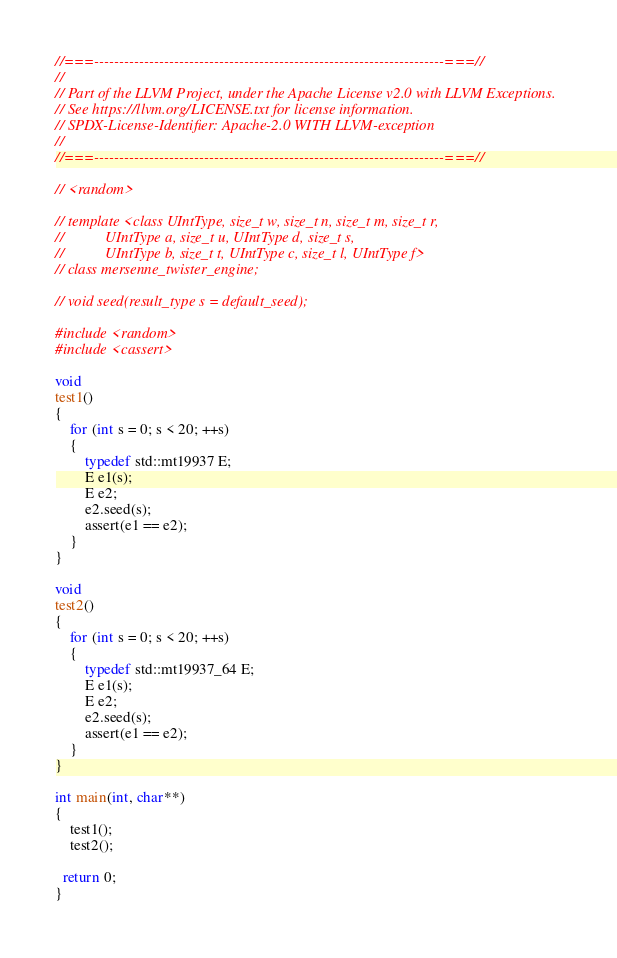Convert code to text. <code><loc_0><loc_0><loc_500><loc_500><_C++_>//===----------------------------------------------------------------------===//
//
// Part of the LLVM Project, under the Apache License v2.0 with LLVM Exceptions.
// See https://llvm.org/LICENSE.txt for license information.
// SPDX-License-Identifier: Apache-2.0 WITH LLVM-exception
//
//===----------------------------------------------------------------------===//

// <random>

// template <class UIntType, size_t w, size_t n, size_t m, size_t r,
//           UIntType a, size_t u, UIntType d, size_t s,
//           UIntType b, size_t t, UIntType c, size_t l, UIntType f>
// class mersenne_twister_engine;

// void seed(result_type s = default_seed);

#include <random>
#include <cassert>

void
test1()
{
    for (int s = 0; s < 20; ++s)
    {
        typedef std::mt19937 E;
        E e1(s);
        E e2;
        e2.seed(s);
        assert(e1 == e2);
    }
}

void
test2()
{
    for (int s = 0; s < 20; ++s)
    {
        typedef std::mt19937_64 E;
        E e1(s);
        E e2;
        e2.seed(s);
        assert(e1 == e2);
    }
}

int main(int, char**)
{
    test1();
    test2();

  return 0;
}
</code> 